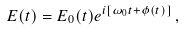Convert formula to latex. <formula><loc_0><loc_0><loc_500><loc_500>E ( t ) = E _ { 0 } ( t ) e ^ { i [ \omega _ { 0 } t + \phi ( t ) ] } \, ,</formula> 